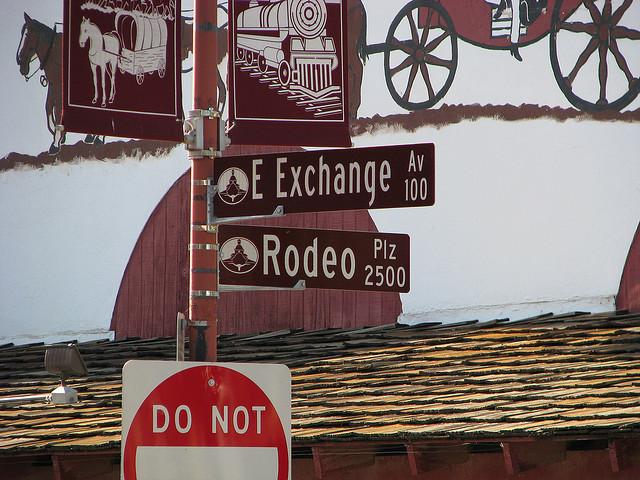What is "E" short for?
Quick response, please. East. What does the second sign say?
Give a very brief answer. Rodeo. What type of roof is this?
Be succinct. Shingle. 